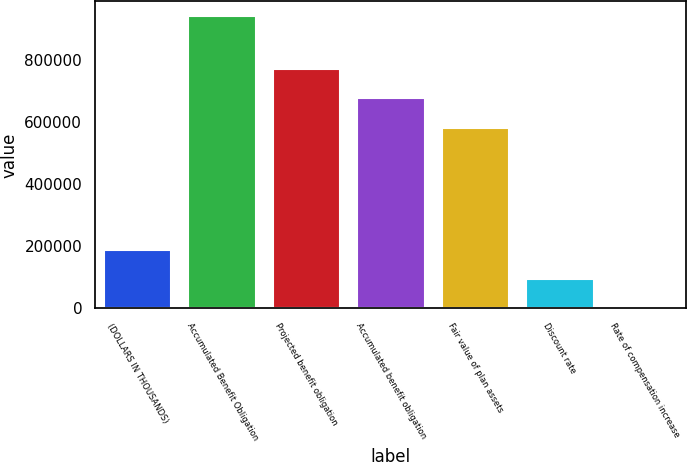Convert chart. <chart><loc_0><loc_0><loc_500><loc_500><bar_chart><fcel>(DOLLARS IN THOUSANDS)<fcel>Accumulated Benefit Obligation<fcel>Projected benefit obligation<fcel>Accumulated benefit obligation<fcel>Fair value of plan assets<fcel>Discount rate<fcel>Rate of compensation increase<nl><fcel>188422<fcel>942103<fcel>770261<fcel>676051<fcel>581841<fcel>94212.1<fcel>2<nl></chart> 